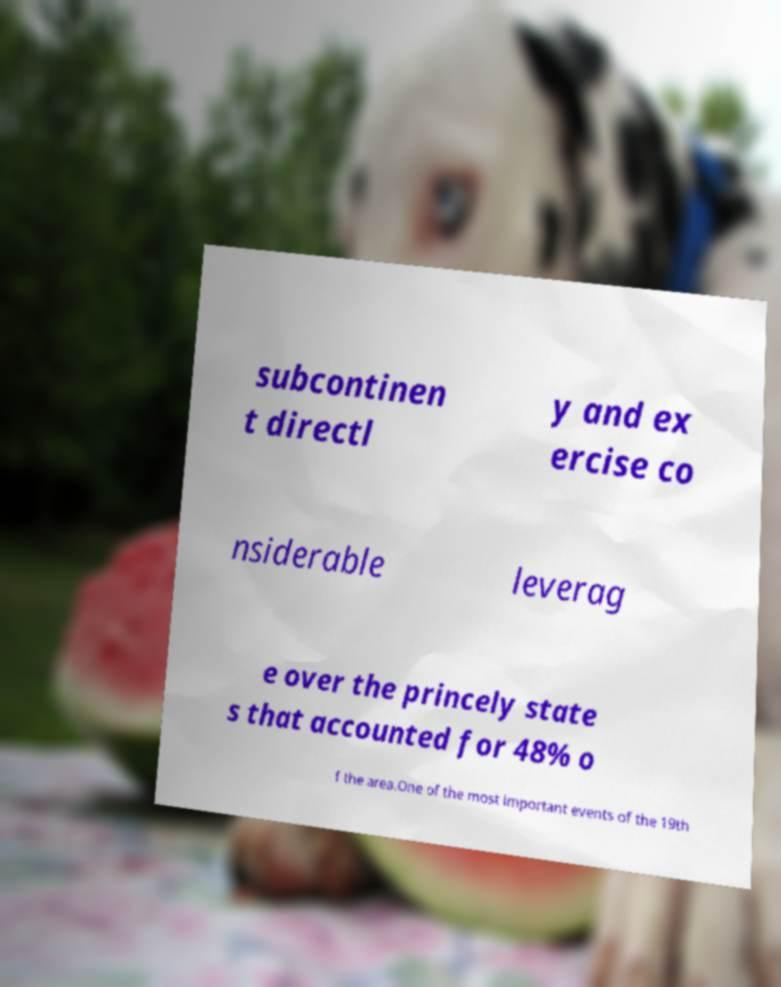Please read and relay the text visible in this image. What does it say? subcontinen t directl y and ex ercise co nsiderable leverag e over the princely state s that accounted for 48% o f the area.One of the most important events of the 19th 